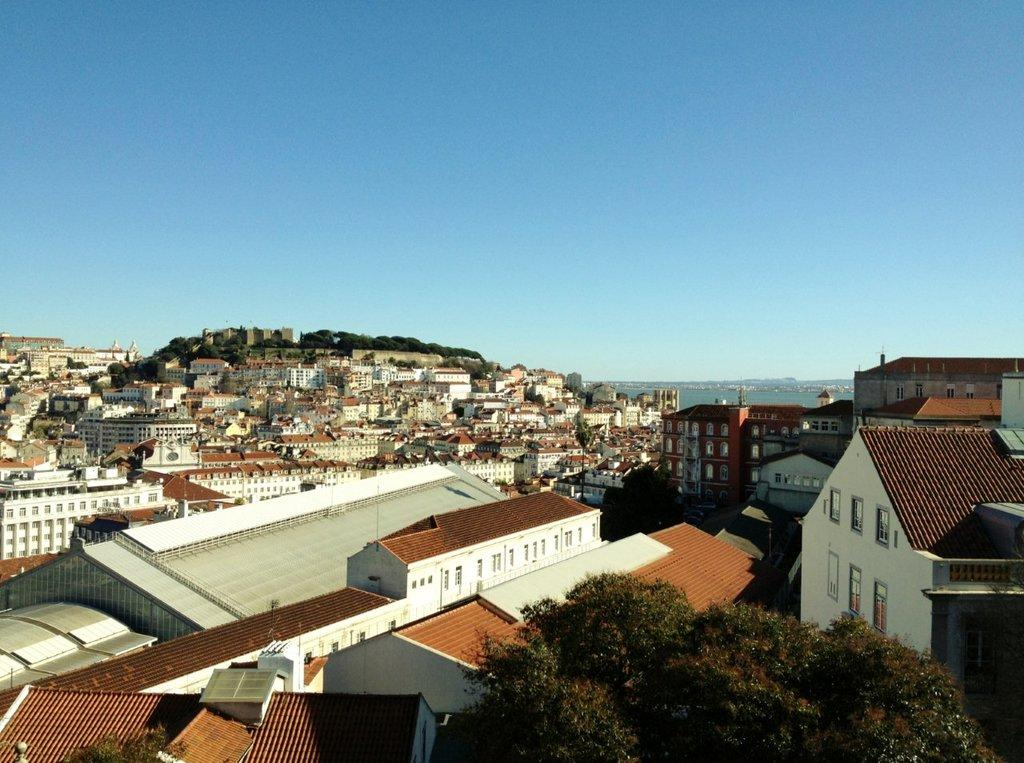What type of structures can be seen in the image? There is a group of buildings in the image, including houses. What other natural elements are present in the image? There are trees and a water body visible in the image. How would you describe the sky in the image? The sky is cloudy in the image. What type of dinner is being served in the image? There is no dinner present in the image; it features a group of buildings, houses, trees, a water body, and a cloudy sky. Can you see any police officers in the image? There are no police officers visible in the image. 